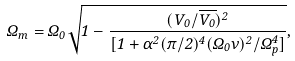<formula> <loc_0><loc_0><loc_500><loc_500>\Omega _ { m } = \Omega _ { 0 } \sqrt { 1 - \frac { ( V _ { 0 } / \overline { V _ { 0 } } ) ^ { 2 } } { [ 1 + \alpha ^ { 2 } ( \pi / 2 ) ^ { 4 } ( \Omega _ { 0 } \nu ) ^ { 2 } / \Omega _ { p } ^ { 4 } ] } } ,</formula> 